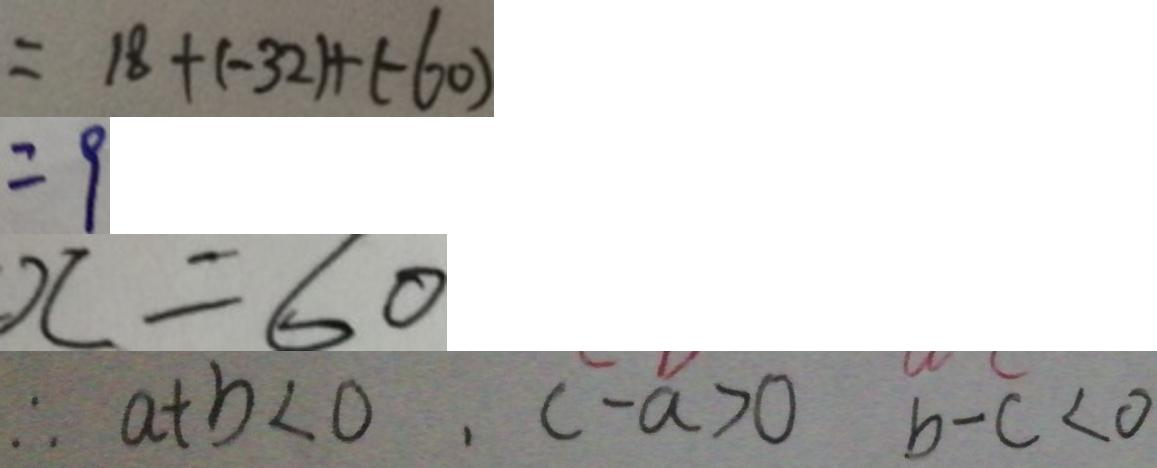<formula> <loc_0><loc_0><loc_500><loc_500>= 1 8 + ( - 3 2 ) + ( - 6 0 ) 
 = 9 
 x = 6 0 
 \therefore a + b < 0 , c - a > 0 b - c < 0</formula> 